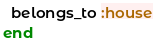Convert code to text. <code><loc_0><loc_0><loc_500><loc_500><_Ruby_>  belongs_to :house
end
</code> 